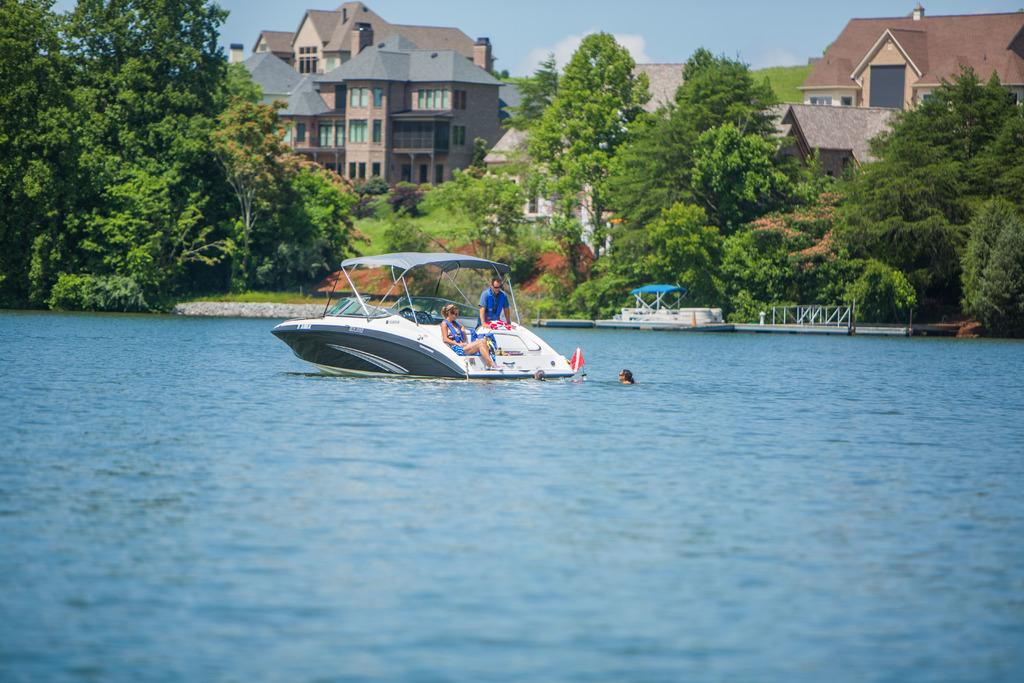What is the main subject of the image? The main subject of the image is a boat in the water. How many people are in the boat? There are two persons in the boat. What can be seen in the background of the image? There are houses and trees in the background of the image. What type of blade is being used to cut the trees in the image? There is no blade or tree-cutting activity depicted in the image; it features a boat with two people in the water, and houses and trees in the background. 